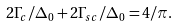<formula> <loc_0><loc_0><loc_500><loc_500>2 \Gamma _ { c } / \Delta _ { 0 } + 2 \Gamma _ { s c } / \Delta _ { 0 } = 4 / \pi .</formula> 